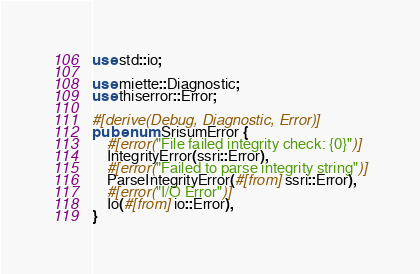Convert code to text. <code><loc_0><loc_0><loc_500><loc_500><_Rust_>use std::io;

use miette::Diagnostic;
use thiserror::Error;

#[derive(Debug, Diagnostic, Error)]
pub enum SrisumError {
    #[error("File failed integrity check: {0}")]
    IntegrityError(ssri::Error),
    #[error("Failed to parse integrity string")]
    ParseIntegrityError(#[from] ssri::Error),
    #[error("I/O Error")]
    Io(#[from] io::Error),
}
</code> 